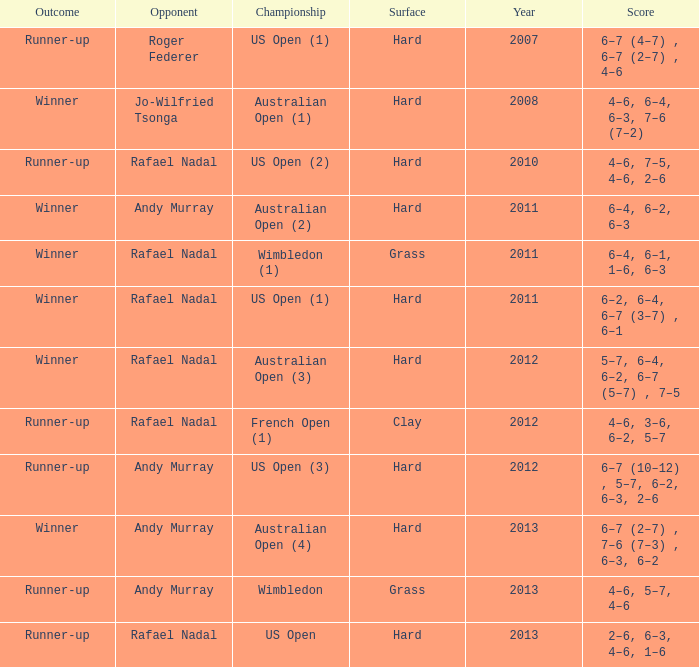What is the outcome of the match with Roger Federer as the opponent? Runner-up. 